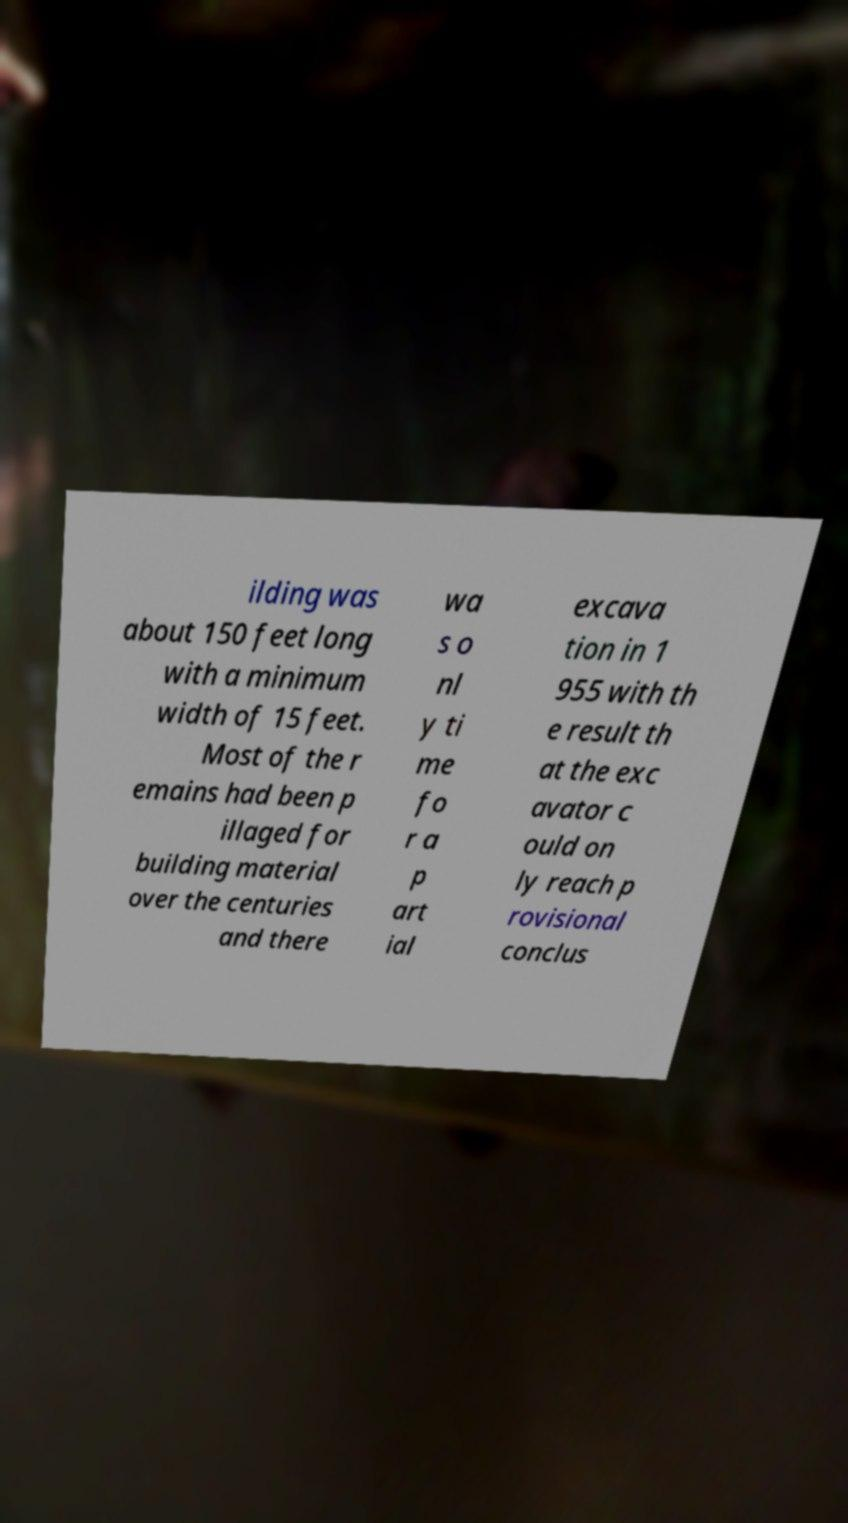For documentation purposes, I need the text within this image transcribed. Could you provide that? ilding was about 150 feet long with a minimum width of 15 feet. Most of the r emains had been p illaged for building material over the centuries and there wa s o nl y ti me fo r a p art ial excava tion in 1 955 with th e result th at the exc avator c ould on ly reach p rovisional conclus 